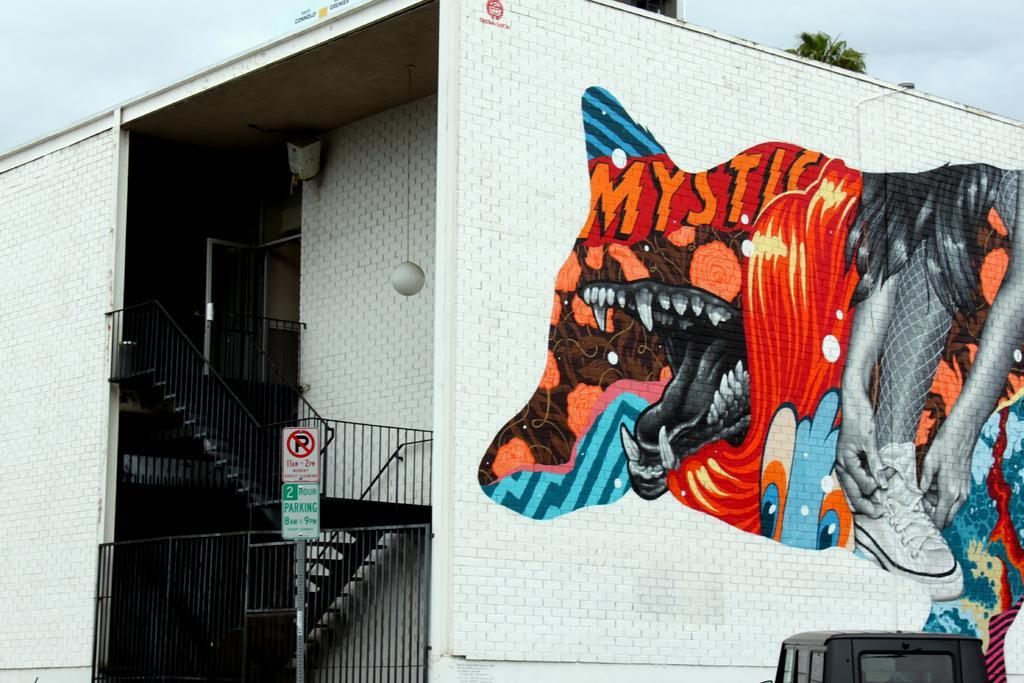In one or two sentences, can you explain what this image depicts? In the image there is a building with walls, steps with railings, door and also there is a ball hanging with the rope. On the walls on the building there is a graffiti. At the bottom of the image there is a vehicle. At the top of the image there is a sky and also we can see few leaves. 